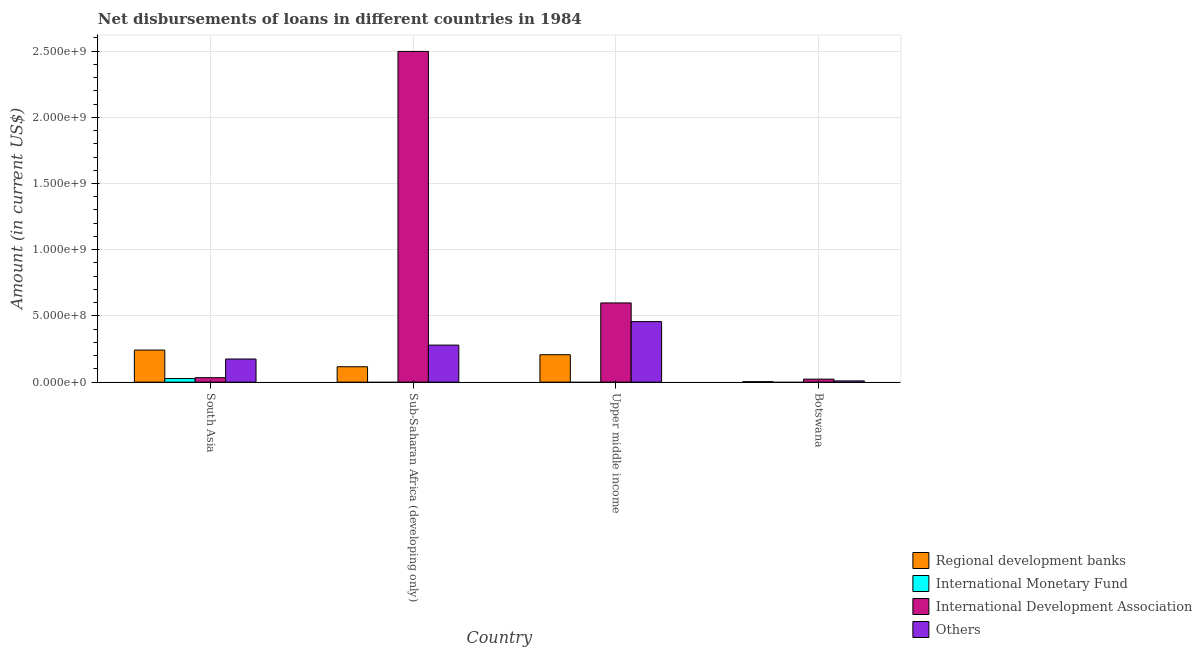How many different coloured bars are there?
Make the answer very short. 4. How many groups of bars are there?
Provide a short and direct response. 4. Are the number of bars per tick equal to the number of legend labels?
Keep it short and to the point. No. How many bars are there on the 2nd tick from the left?
Your response must be concise. 3. What is the label of the 3rd group of bars from the left?
Your answer should be compact. Upper middle income. In how many cases, is the number of bars for a given country not equal to the number of legend labels?
Offer a terse response. 3. What is the amount of loan disimbursed by international development association in Sub-Saharan Africa (developing only)?
Make the answer very short. 2.50e+09. Across all countries, what is the maximum amount of loan disimbursed by other organisations?
Your answer should be very brief. 4.57e+08. In which country was the amount of loan disimbursed by other organisations maximum?
Your answer should be compact. Upper middle income. What is the total amount of loan disimbursed by international monetary fund in the graph?
Give a very brief answer. 2.70e+07. What is the difference between the amount of loan disimbursed by other organisations in Botswana and that in Sub-Saharan Africa (developing only)?
Provide a succinct answer. -2.70e+08. What is the difference between the amount of loan disimbursed by international monetary fund in Upper middle income and the amount of loan disimbursed by other organisations in Botswana?
Make the answer very short. -9.29e+06. What is the average amount of loan disimbursed by regional development banks per country?
Your answer should be very brief. 1.42e+08. What is the difference between the amount of loan disimbursed by regional development banks and amount of loan disimbursed by other organisations in South Asia?
Your answer should be compact. 6.75e+07. What is the ratio of the amount of loan disimbursed by regional development banks in Sub-Saharan Africa (developing only) to that in Upper middle income?
Offer a very short reply. 0.56. Is the difference between the amount of loan disimbursed by regional development banks in Sub-Saharan Africa (developing only) and Upper middle income greater than the difference between the amount of loan disimbursed by other organisations in Sub-Saharan Africa (developing only) and Upper middle income?
Provide a short and direct response. Yes. What is the difference between the highest and the second highest amount of loan disimbursed by international development association?
Keep it short and to the point. 1.90e+09. What is the difference between the highest and the lowest amount of loan disimbursed by international monetary fund?
Keep it short and to the point. 2.70e+07. Are all the bars in the graph horizontal?
Make the answer very short. No. How many countries are there in the graph?
Your response must be concise. 4. What is the difference between two consecutive major ticks on the Y-axis?
Keep it short and to the point. 5.00e+08. Does the graph contain any zero values?
Give a very brief answer. Yes. How are the legend labels stacked?
Ensure brevity in your answer.  Vertical. What is the title of the graph?
Give a very brief answer. Net disbursements of loans in different countries in 1984. Does "European Union" appear as one of the legend labels in the graph?
Your response must be concise. No. What is the label or title of the Y-axis?
Offer a very short reply. Amount (in current US$). What is the Amount (in current US$) in Regional development banks in South Asia?
Make the answer very short. 2.42e+08. What is the Amount (in current US$) of International Monetary Fund in South Asia?
Ensure brevity in your answer.  2.70e+07. What is the Amount (in current US$) of International Development Association in South Asia?
Offer a very short reply. 3.37e+07. What is the Amount (in current US$) of Others in South Asia?
Ensure brevity in your answer.  1.75e+08. What is the Amount (in current US$) in Regional development banks in Sub-Saharan Africa (developing only)?
Make the answer very short. 1.16e+08. What is the Amount (in current US$) of International Development Association in Sub-Saharan Africa (developing only)?
Your answer should be compact. 2.50e+09. What is the Amount (in current US$) in Others in Sub-Saharan Africa (developing only)?
Your answer should be very brief. 2.80e+08. What is the Amount (in current US$) in Regional development banks in Upper middle income?
Ensure brevity in your answer.  2.07e+08. What is the Amount (in current US$) of International Monetary Fund in Upper middle income?
Provide a succinct answer. 0. What is the Amount (in current US$) of International Development Association in Upper middle income?
Your response must be concise. 5.98e+08. What is the Amount (in current US$) of Others in Upper middle income?
Provide a succinct answer. 4.57e+08. What is the Amount (in current US$) of Regional development banks in Botswana?
Your response must be concise. 3.62e+06. What is the Amount (in current US$) in International Development Association in Botswana?
Offer a very short reply. 2.27e+07. What is the Amount (in current US$) of Others in Botswana?
Your response must be concise. 9.29e+06. Across all countries, what is the maximum Amount (in current US$) of Regional development banks?
Ensure brevity in your answer.  2.42e+08. Across all countries, what is the maximum Amount (in current US$) in International Monetary Fund?
Your response must be concise. 2.70e+07. Across all countries, what is the maximum Amount (in current US$) of International Development Association?
Provide a short and direct response. 2.50e+09. Across all countries, what is the maximum Amount (in current US$) in Others?
Your answer should be very brief. 4.57e+08. Across all countries, what is the minimum Amount (in current US$) of Regional development banks?
Offer a very short reply. 3.62e+06. Across all countries, what is the minimum Amount (in current US$) in International Monetary Fund?
Offer a terse response. 0. Across all countries, what is the minimum Amount (in current US$) in International Development Association?
Your response must be concise. 2.27e+07. Across all countries, what is the minimum Amount (in current US$) of Others?
Keep it short and to the point. 9.29e+06. What is the total Amount (in current US$) in Regional development banks in the graph?
Your response must be concise. 5.69e+08. What is the total Amount (in current US$) of International Monetary Fund in the graph?
Ensure brevity in your answer.  2.70e+07. What is the total Amount (in current US$) of International Development Association in the graph?
Provide a succinct answer. 3.15e+09. What is the total Amount (in current US$) in Others in the graph?
Offer a terse response. 9.21e+08. What is the difference between the Amount (in current US$) in Regional development banks in South Asia and that in Sub-Saharan Africa (developing only)?
Ensure brevity in your answer.  1.26e+08. What is the difference between the Amount (in current US$) in International Development Association in South Asia and that in Sub-Saharan Africa (developing only)?
Offer a terse response. -2.46e+09. What is the difference between the Amount (in current US$) of Others in South Asia and that in Sub-Saharan Africa (developing only)?
Provide a succinct answer. -1.05e+08. What is the difference between the Amount (in current US$) of Regional development banks in South Asia and that in Upper middle income?
Your response must be concise. 3.52e+07. What is the difference between the Amount (in current US$) in International Development Association in South Asia and that in Upper middle income?
Provide a short and direct response. -5.64e+08. What is the difference between the Amount (in current US$) in Others in South Asia and that in Upper middle income?
Give a very brief answer. -2.82e+08. What is the difference between the Amount (in current US$) of Regional development banks in South Asia and that in Botswana?
Provide a succinct answer. 2.39e+08. What is the difference between the Amount (in current US$) of International Development Association in South Asia and that in Botswana?
Your answer should be compact. 1.10e+07. What is the difference between the Amount (in current US$) in Others in South Asia and that in Botswana?
Your response must be concise. 1.65e+08. What is the difference between the Amount (in current US$) in Regional development banks in Sub-Saharan Africa (developing only) and that in Upper middle income?
Provide a short and direct response. -9.08e+07. What is the difference between the Amount (in current US$) of International Development Association in Sub-Saharan Africa (developing only) and that in Upper middle income?
Your response must be concise. 1.90e+09. What is the difference between the Amount (in current US$) in Others in Sub-Saharan Africa (developing only) and that in Upper middle income?
Keep it short and to the point. -1.77e+08. What is the difference between the Amount (in current US$) of Regional development banks in Sub-Saharan Africa (developing only) and that in Botswana?
Ensure brevity in your answer.  1.13e+08. What is the difference between the Amount (in current US$) of International Development Association in Sub-Saharan Africa (developing only) and that in Botswana?
Give a very brief answer. 2.47e+09. What is the difference between the Amount (in current US$) in Others in Sub-Saharan Africa (developing only) and that in Botswana?
Make the answer very short. 2.70e+08. What is the difference between the Amount (in current US$) of Regional development banks in Upper middle income and that in Botswana?
Make the answer very short. 2.03e+08. What is the difference between the Amount (in current US$) of International Development Association in Upper middle income and that in Botswana?
Your answer should be compact. 5.75e+08. What is the difference between the Amount (in current US$) of Others in Upper middle income and that in Botswana?
Make the answer very short. 4.48e+08. What is the difference between the Amount (in current US$) in Regional development banks in South Asia and the Amount (in current US$) in International Development Association in Sub-Saharan Africa (developing only)?
Your response must be concise. -2.26e+09. What is the difference between the Amount (in current US$) in Regional development banks in South Asia and the Amount (in current US$) in Others in Sub-Saharan Africa (developing only)?
Offer a terse response. -3.75e+07. What is the difference between the Amount (in current US$) in International Monetary Fund in South Asia and the Amount (in current US$) in International Development Association in Sub-Saharan Africa (developing only)?
Give a very brief answer. -2.47e+09. What is the difference between the Amount (in current US$) in International Monetary Fund in South Asia and the Amount (in current US$) in Others in Sub-Saharan Africa (developing only)?
Ensure brevity in your answer.  -2.53e+08. What is the difference between the Amount (in current US$) in International Development Association in South Asia and the Amount (in current US$) in Others in Sub-Saharan Africa (developing only)?
Offer a very short reply. -2.46e+08. What is the difference between the Amount (in current US$) of Regional development banks in South Asia and the Amount (in current US$) of International Development Association in Upper middle income?
Keep it short and to the point. -3.56e+08. What is the difference between the Amount (in current US$) in Regional development banks in South Asia and the Amount (in current US$) in Others in Upper middle income?
Offer a very short reply. -2.15e+08. What is the difference between the Amount (in current US$) of International Monetary Fund in South Asia and the Amount (in current US$) of International Development Association in Upper middle income?
Provide a short and direct response. -5.71e+08. What is the difference between the Amount (in current US$) in International Monetary Fund in South Asia and the Amount (in current US$) in Others in Upper middle income?
Keep it short and to the point. -4.30e+08. What is the difference between the Amount (in current US$) of International Development Association in South Asia and the Amount (in current US$) of Others in Upper middle income?
Your response must be concise. -4.23e+08. What is the difference between the Amount (in current US$) in Regional development banks in South Asia and the Amount (in current US$) in International Development Association in Botswana?
Make the answer very short. 2.20e+08. What is the difference between the Amount (in current US$) in Regional development banks in South Asia and the Amount (in current US$) in Others in Botswana?
Offer a very short reply. 2.33e+08. What is the difference between the Amount (in current US$) in International Monetary Fund in South Asia and the Amount (in current US$) in International Development Association in Botswana?
Offer a terse response. 4.26e+06. What is the difference between the Amount (in current US$) of International Monetary Fund in South Asia and the Amount (in current US$) of Others in Botswana?
Your answer should be compact. 1.77e+07. What is the difference between the Amount (in current US$) in International Development Association in South Asia and the Amount (in current US$) in Others in Botswana?
Offer a very short reply. 2.44e+07. What is the difference between the Amount (in current US$) of Regional development banks in Sub-Saharan Africa (developing only) and the Amount (in current US$) of International Development Association in Upper middle income?
Offer a terse response. -4.82e+08. What is the difference between the Amount (in current US$) of Regional development banks in Sub-Saharan Africa (developing only) and the Amount (in current US$) of Others in Upper middle income?
Your response must be concise. -3.41e+08. What is the difference between the Amount (in current US$) in International Development Association in Sub-Saharan Africa (developing only) and the Amount (in current US$) in Others in Upper middle income?
Offer a very short reply. 2.04e+09. What is the difference between the Amount (in current US$) in Regional development banks in Sub-Saharan Africa (developing only) and the Amount (in current US$) in International Development Association in Botswana?
Provide a succinct answer. 9.36e+07. What is the difference between the Amount (in current US$) of Regional development banks in Sub-Saharan Africa (developing only) and the Amount (in current US$) of Others in Botswana?
Provide a succinct answer. 1.07e+08. What is the difference between the Amount (in current US$) of International Development Association in Sub-Saharan Africa (developing only) and the Amount (in current US$) of Others in Botswana?
Give a very brief answer. 2.49e+09. What is the difference between the Amount (in current US$) in Regional development banks in Upper middle income and the Amount (in current US$) in International Development Association in Botswana?
Your response must be concise. 1.84e+08. What is the difference between the Amount (in current US$) in Regional development banks in Upper middle income and the Amount (in current US$) in Others in Botswana?
Offer a terse response. 1.98e+08. What is the difference between the Amount (in current US$) of International Development Association in Upper middle income and the Amount (in current US$) of Others in Botswana?
Ensure brevity in your answer.  5.89e+08. What is the average Amount (in current US$) of Regional development banks per country?
Ensure brevity in your answer.  1.42e+08. What is the average Amount (in current US$) in International Monetary Fund per country?
Keep it short and to the point. 6.74e+06. What is the average Amount (in current US$) of International Development Association per country?
Make the answer very short. 7.88e+08. What is the average Amount (in current US$) in Others per country?
Ensure brevity in your answer.  2.30e+08. What is the difference between the Amount (in current US$) of Regional development banks and Amount (in current US$) of International Monetary Fund in South Asia?
Give a very brief answer. 2.15e+08. What is the difference between the Amount (in current US$) in Regional development banks and Amount (in current US$) in International Development Association in South Asia?
Provide a succinct answer. 2.09e+08. What is the difference between the Amount (in current US$) of Regional development banks and Amount (in current US$) of Others in South Asia?
Offer a terse response. 6.75e+07. What is the difference between the Amount (in current US$) of International Monetary Fund and Amount (in current US$) of International Development Association in South Asia?
Offer a terse response. -6.76e+06. What is the difference between the Amount (in current US$) of International Monetary Fund and Amount (in current US$) of Others in South Asia?
Give a very brief answer. -1.48e+08. What is the difference between the Amount (in current US$) of International Development Association and Amount (in current US$) of Others in South Asia?
Your answer should be compact. -1.41e+08. What is the difference between the Amount (in current US$) of Regional development banks and Amount (in current US$) of International Development Association in Sub-Saharan Africa (developing only)?
Ensure brevity in your answer.  -2.38e+09. What is the difference between the Amount (in current US$) in Regional development banks and Amount (in current US$) in Others in Sub-Saharan Africa (developing only)?
Give a very brief answer. -1.63e+08. What is the difference between the Amount (in current US$) in International Development Association and Amount (in current US$) in Others in Sub-Saharan Africa (developing only)?
Make the answer very short. 2.22e+09. What is the difference between the Amount (in current US$) in Regional development banks and Amount (in current US$) in International Development Association in Upper middle income?
Give a very brief answer. -3.91e+08. What is the difference between the Amount (in current US$) in Regional development banks and Amount (in current US$) in Others in Upper middle income?
Give a very brief answer. -2.50e+08. What is the difference between the Amount (in current US$) in International Development Association and Amount (in current US$) in Others in Upper middle income?
Provide a short and direct response. 1.41e+08. What is the difference between the Amount (in current US$) of Regional development banks and Amount (in current US$) of International Development Association in Botswana?
Provide a succinct answer. -1.91e+07. What is the difference between the Amount (in current US$) in Regional development banks and Amount (in current US$) in Others in Botswana?
Provide a short and direct response. -5.67e+06. What is the difference between the Amount (in current US$) of International Development Association and Amount (in current US$) of Others in Botswana?
Keep it short and to the point. 1.34e+07. What is the ratio of the Amount (in current US$) of Regional development banks in South Asia to that in Sub-Saharan Africa (developing only)?
Keep it short and to the point. 2.08. What is the ratio of the Amount (in current US$) in International Development Association in South Asia to that in Sub-Saharan Africa (developing only)?
Provide a succinct answer. 0.01. What is the ratio of the Amount (in current US$) in Others in South Asia to that in Sub-Saharan Africa (developing only)?
Your answer should be compact. 0.62. What is the ratio of the Amount (in current US$) in Regional development banks in South Asia to that in Upper middle income?
Offer a very short reply. 1.17. What is the ratio of the Amount (in current US$) in International Development Association in South Asia to that in Upper middle income?
Keep it short and to the point. 0.06. What is the ratio of the Amount (in current US$) of Others in South Asia to that in Upper middle income?
Ensure brevity in your answer.  0.38. What is the ratio of the Amount (in current US$) in Regional development banks in South Asia to that in Botswana?
Offer a terse response. 66.87. What is the ratio of the Amount (in current US$) in International Development Association in South Asia to that in Botswana?
Provide a succinct answer. 1.49. What is the ratio of the Amount (in current US$) in Others in South Asia to that in Botswana?
Your answer should be compact. 18.81. What is the ratio of the Amount (in current US$) of Regional development banks in Sub-Saharan Africa (developing only) to that in Upper middle income?
Offer a terse response. 0.56. What is the ratio of the Amount (in current US$) in International Development Association in Sub-Saharan Africa (developing only) to that in Upper middle income?
Your answer should be very brief. 4.17. What is the ratio of the Amount (in current US$) of Others in Sub-Saharan Africa (developing only) to that in Upper middle income?
Your answer should be compact. 0.61. What is the ratio of the Amount (in current US$) of Regional development banks in Sub-Saharan Africa (developing only) to that in Botswana?
Give a very brief answer. 32.09. What is the ratio of the Amount (in current US$) in International Development Association in Sub-Saharan Africa (developing only) to that in Botswana?
Your answer should be very brief. 109.93. What is the ratio of the Amount (in current US$) of Others in Sub-Saharan Africa (developing only) to that in Botswana?
Provide a succinct answer. 30.11. What is the ratio of the Amount (in current US$) in Regional development banks in Upper middle income to that in Botswana?
Provide a succinct answer. 57.15. What is the ratio of the Amount (in current US$) of International Development Association in Upper middle income to that in Botswana?
Make the answer very short. 26.33. What is the ratio of the Amount (in current US$) in Others in Upper middle income to that in Botswana?
Offer a terse response. 49.2. What is the difference between the highest and the second highest Amount (in current US$) in Regional development banks?
Keep it short and to the point. 3.52e+07. What is the difference between the highest and the second highest Amount (in current US$) of International Development Association?
Offer a terse response. 1.90e+09. What is the difference between the highest and the second highest Amount (in current US$) of Others?
Offer a terse response. 1.77e+08. What is the difference between the highest and the lowest Amount (in current US$) in Regional development banks?
Provide a succinct answer. 2.39e+08. What is the difference between the highest and the lowest Amount (in current US$) of International Monetary Fund?
Give a very brief answer. 2.70e+07. What is the difference between the highest and the lowest Amount (in current US$) of International Development Association?
Provide a short and direct response. 2.47e+09. What is the difference between the highest and the lowest Amount (in current US$) of Others?
Ensure brevity in your answer.  4.48e+08. 